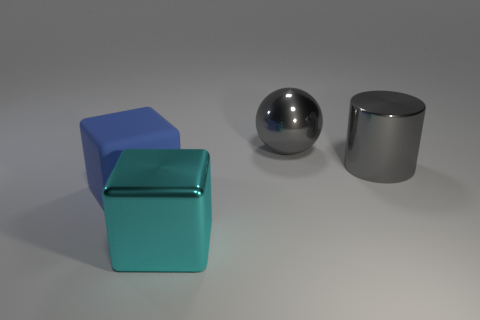There is a metal object that is both to the left of the cylinder and behind the matte thing; what size is it?
Give a very brief answer. Large. Is the material of the cube that is behind the big metallic cube the same as the big block that is in front of the blue rubber block?
Offer a terse response. No. There is a cyan metal thing that is the same size as the matte block; what shape is it?
Keep it short and to the point. Cube. Is the number of gray shiny objects less than the number of tiny yellow balls?
Provide a succinct answer. No. There is a cube that is behind the big cyan block; are there any blue matte blocks that are in front of it?
Offer a very short reply. No. Is there a rubber object that is in front of the cube that is behind the big object in front of the large blue rubber cube?
Your answer should be very brief. No. Does the big cyan shiny thing that is to the left of the big gray metal cylinder have the same shape as the gray object that is left of the big metal cylinder?
Offer a very short reply. No. There is a block that is the same material as the big cylinder; what is its color?
Your answer should be compact. Cyan. Is the number of big things behind the gray sphere less than the number of gray matte blocks?
Offer a terse response. No. There is a thing on the left side of the large block in front of the block behind the large cyan metal block; how big is it?
Provide a succinct answer. Large. 